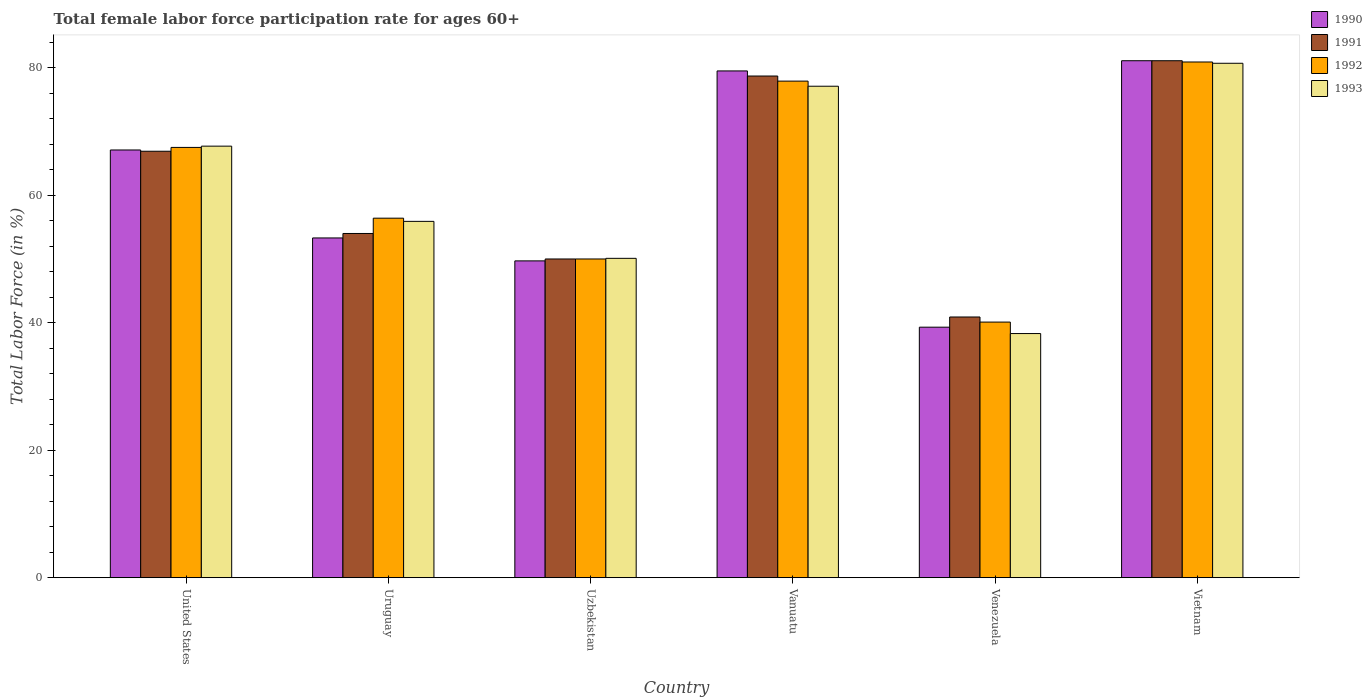How many bars are there on the 1st tick from the left?
Make the answer very short. 4. What is the label of the 4th group of bars from the left?
Your response must be concise. Vanuatu. In how many cases, is the number of bars for a given country not equal to the number of legend labels?
Make the answer very short. 0. What is the female labor force participation rate in 1993 in Uzbekistan?
Your answer should be compact. 50.1. Across all countries, what is the maximum female labor force participation rate in 1992?
Provide a short and direct response. 80.9. Across all countries, what is the minimum female labor force participation rate in 1990?
Your response must be concise. 39.3. In which country was the female labor force participation rate in 1993 maximum?
Provide a succinct answer. Vietnam. In which country was the female labor force participation rate in 1991 minimum?
Make the answer very short. Venezuela. What is the total female labor force participation rate in 1991 in the graph?
Provide a succinct answer. 371.6. What is the difference between the female labor force participation rate in 1991 in United States and that in Venezuela?
Give a very brief answer. 26. What is the difference between the female labor force participation rate in 1993 in Uzbekistan and the female labor force participation rate in 1990 in Venezuela?
Your answer should be compact. 10.8. What is the average female labor force participation rate in 1993 per country?
Your answer should be very brief. 61.63. What is the difference between the female labor force participation rate of/in 1993 and female labor force participation rate of/in 1991 in Uruguay?
Ensure brevity in your answer.  1.9. What is the ratio of the female labor force participation rate in 1991 in Uruguay to that in Venezuela?
Make the answer very short. 1.32. Is the difference between the female labor force participation rate in 1993 in Uruguay and Uzbekistan greater than the difference between the female labor force participation rate in 1991 in Uruguay and Uzbekistan?
Ensure brevity in your answer.  Yes. What is the difference between the highest and the lowest female labor force participation rate in 1993?
Make the answer very short. 42.4. Is the sum of the female labor force participation rate in 1992 in Uruguay and Vietnam greater than the maximum female labor force participation rate in 1990 across all countries?
Make the answer very short. Yes. What does the 4th bar from the left in Uzbekistan represents?
Provide a short and direct response. 1993. What does the 2nd bar from the right in Uzbekistan represents?
Keep it short and to the point. 1992. Are all the bars in the graph horizontal?
Your answer should be very brief. No. How many countries are there in the graph?
Your answer should be compact. 6. What is the difference between two consecutive major ticks on the Y-axis?
Keep it short and to the point. 20. Are the values on the major ticks of Y-axis written in scientific E-notation?
Ensure brevity in your answer.  No. Does the graph contain grids?
Give a very brief answer. No. How many legend labels are there?
Give a very brief answer. 4. How are the legend labels stacked?
Provide a short and direct response. Vertical. What is the title of the graph?
Provide a succinct answer. Total female labor force participation rate for ages 60+. Does "2001" appear as one of the legend labels in the graph?
Ensure brevity in your answer.  No. What is the Total Labor Force (in %) of 1990 in United States?
Your answer should be compact. 67.1. What is the Total Labor Force (in %) of 1991 in United States?
Provide a succinct answer. 66.9. What is the Total Labor Force (in %) in 1992 in United States?
Offer a terse response. 67.5. What is the Total Labor Force (in %) in 1993 in United States?
Provide a succinct answer. 67.7. What is the Total Labor Force (in %) in 1990 in Uruguay?
Your answer should be compact. 53.3. What is the Total Labor Force (in %) in 1991 in Uruguay?
Offer a very short reply. 54. What is the Total Labor Force (in %) in 1992 in Uruguay?
Offer a terse response. 56.4. What is the Total Labor Force (in %) in 1993 in Uruguay?
Offer a very short reply. 55.9. What is the Total Labor Force (in %) of 1990 in Uzbekistan?
Provide a short and direct response. 49.7. What is the Total Labor Force (in %) of 1993 in Uzbekistan?
Provide a succinct answer. 50.1. What is the Total Labor Force (in %) of 1990 in Vanuatu?
Provide a succinct answer. 79.5. What is the Total Labor Force (in %) in 1991 in Vanuatu?
Your response must be concise. 78.7. What is the Total Labor Force (in %) of 1992 in Vanuatu?
Provide a short and direct response. 77.9. What is the Total Labor Force (in %) of 1993 in Vanuatu?
Provide a short and direct response. 77.1. What is the Total Labor Force (in %) in 1990 in Venezuela?
Your answer should be compact. 39.3. What is the Total Labor Force (in %) in 1991 in Venezuela?
Make the answer very short. 40.9. What is the Total Labor Force (in %) in 1992 in Venezuela?
Make the answer very short. 40.1. What is the Total Labor Force (in %) of 1993 in Venezuela?
Offer a very short reply. 38.3. What is the Total Labor Force (in %) of 1990 in Vietnam?
Offer a very short reply. 81.1. What is the Total Labor Force (in %) in 1991 in Vietnam?
Your answer should be very brief. 81.1. What is the Total Labor Force (in %) of 1992 in Vietnam?
Ensure brevity in your answer.  80.9. What is the Total Labor Force (in %) of 1993 in Vietnam?
Give a very brief answer. 80.7. Across all countries, what is the maximum Total Labor Force (in %) in 1990?
Ensure brevity in your answer.  81.1. Across all countries, what is the maximum Total Labor Force (in %) of 1991?
Your answer should be very brief. 81.1. Across all countries, what is the maximum Total Labor Force (in %) in 1992?
Offer a very short reply. 80.9. Across all countries, what is the maximum Total Labor Force (in %) of 1993?
Give a very brief answer. 80.7. Across all countries, what is the minimum Total Labor Force (in %) of 1990?
Keep it short and to the point. 39.3. Across all countries, what is the minimum Total Labor Force (in %) in 1991?
Ensure brevity in your answer.  40.9. Across all countries, what is the minimum Total Labor Force (in %) of 1992?
Give a very brief answer. 40.1. Across all countries, what is the minimum Total Labor Force (in %) of 1993?
Offer a terse response. 38.3. What is the total Total Labor Force (in %) of 1990 in the graph?
Provide a succinct answer. 370. What is the total Total Labor Force (in %) in 1991 in the graph?
Offer a terse response. 371.6. What is the total Total Labor Force (in %) in 1992 in the graph?
Offer a very short reply. 372.8. What is the total Total Labor Force (in %) of 1993 in the graph?
Ensure brevity in your answer.  369.8. What is the difference between the Total Labor Force (in %) in 1992 in United States and that in Uruguay?
Make the answer very short. 11.1. What is the difference between the Total Labor Force (in %) of 1992 in United States and that in Uzbekistan?
Provide a short and direct response. 17.5. What is the difference between the Total Labor Force (in %) in 1993 in United States and that in Uzbekistan?
Keep it short and to the point. 17.6. What is the difference between the Total Labor Force (in %) in 1991 in United States and that in Vanuatu?
Offer a terse response. -11.8. What is the difference between the Total Labor Force (in %) in 1992 in United States and that in Vanuatu?
Provide a short and direct response. -10.4. What is the difference between the Total Labor Force (in %) in 1993 in United States and that in Vanuatu?
Give a very brief answer. -9.4. What is the difference between the Total Labor Force (in %) in 1990 in United States and that in Venezuela?
Make the answer very short. 27.8. What is the difference between the Total Labor Force (in %) in 1991 in United States and that in Venezuela?
Your answer should be compact. 26. What is the difference between the Total Labor Force (in %) in 1992 in United States and that in Venezuela?
Provide a succinct answer. 27.4. What is the difference between the Total Labor Force (in %) in 1993 in United States and that in Venezuela?
Provide a short and direct response. 29.4. What is the difference between the Total Labor Force (in %) of 1990 in United States and that in Vietnam?
Keep it short and to the point. -14. What is the difference between the Total Labor Force (in %) in 1992 in United States and that in Vietnam?
Give a very brief answer. -13.4. What is the difference between the Total Labor Force (in %) in 1993 in United States and that in Vietnam?
Make the answer very short. -13. What is the difference between the Total Labor Force (in %) of 1990 in Uruguay and that in Uzbekistan?
Offer a very short reply. 3.6. What is the difference between the Total Labor Force (in %) in 1992 in Uruguay and that in Uzbekistan?
Give a very brief answer. 6.4. What is the difference between the Total Labor Force (in %) of 1990 in Uruguay and that in Vanuatu?
Your response must be concise. -26.2. What is the difference between the Total Labor Force (in %) in 1991 in Uruguay and that in Vanuatu?
Your response must be concise. -24.7. What is the difference between the Total Labor Force (in %) of 1992 in Uruguay and that in Vanuatu?
Ensure brevity in your answer.  -21.5. What is the difference between the Total Labor Force (in %) of 1993 in Uruguay and that in Vanuatu?
Keep it short and to the point. -21.2. What is the difference between the Total Labor Force (in %) in 1990 in Uruguay and that in Venezuela?
Give a very brief answer. 14. What is the difference between the Total Labor Force (in %) of 1992 in Uruguay and that in Venezuela?
Keep it short and to the point. 16.3. What is the difference between the Total Labor Force (in %) of 1993 in Uruguay and that in Venezuela?
Offer a very short reply. 17.6. What is the difference between the Total Labor Force (in %) of 1990 in Uruguay and that in Vietnam?
Your answer should be very brief. -27.8. What is the difference between the Total Labor Force (in %) of 1991 in Uruguay and that in Vietnam?
Your answer should be compact. -27.1. What is the difference between the Total Labor Force (in %) of 1992 in Uruguay and that in Vietnam?
Make the answer very short. -24.5. What is the difference between the Total Labor Force (in %) of 1993 in Uruguay and that in Vietnam?
Your response must be concise. -24.8. What is the difference between the Total Labor Force (in %) in 1990 in Uzbekistan and that in Vanuatu?
Make the answer very short. -29.8. What is the difference between the Total Labor Force (in %) of 1991 in Uzbekistan and that in Vanuatu?
Ensure brevity in your answer.  -28.7. What is the difference between the Total Labor Force (in %) in 1992 in Uzbekistan and that in Vanuatu?
Give a very brief answer. -27.9. What is the difference between the Total Labor Force (in %) of 1993 in Uzbekistan and that in Venezuela?
Your answer should be very brief. 11.8. What is the difference between the Total Labor Force (in %) of 1990 in Uzbekistan and that in Vietnam?
Offer a very short reply. -31.4. What is the difference between the Total Labor Force (in %) of 1991 in Uzbekistan and that in Vietnam?
Offer a terse response. -31.1. What is the difference between the Total Labor Force (in %) in 1992 in Uzbekistan and that in Vietnam?
Provide a succinct answer. -30.9. What is the difference between the Total Labor Force (in %) in 1993 in Uzbekistan and that in Vietnam?
Provide a succinct answer. -30.6. What is the difference between the Total Labor Force (in %) in 1990 in Vanuatu and that in Venezuela?
Give a very brief answer. 40.2. What is the difference between the Total Labor Force (in %) of 1991 in Vanuatu and that in Venezuela?
Give a very brief answer. 37.8. What is the difference between the Total Labor Force (in %) of 1992 in Vanuatu and that in Venezuela?
Your answer should be compact. 37.8. What is the difference between the Total Labor Force (in %) of 1993 in Vanuatu and that in Venezuela?
Make the answer very short. 38.8. What is the difference between the Total Labor Force (in %) of 1991 in Vanuatu and that in Vietnam?
Provide a short and direct response. -2.4. What is the difference between the Total Labor Force (in %) of 1990 in Venezuela and that in Vietnam?
Give a very brief answer. -41.8. What is the difference between the Total Labor Force (in %) of 1991 in Venezuela and that in Vietnam?
Offer a terse response. -40.2. What is the difference between the Total Labor Force (in %) of 1992 in Venezuela and that in Vietnam?
Offer a very short reply. -40.8. What is the difference between the Total Labor Force (in %) of 1993 in Venezuela and that in Vietnam?
Offer a very short reply. -42.4. What is the difference between the Total Labor Force (in %) of 1990 in United States and the Total Labor Force (in %) of 1992 in Uruguay?
Provide a short and direct response. 10.7. What is the difference between the Total Labor Force (in %) in 1990 in United States and the Total Labor Force (in %) in 1993 in Uruguay?
Make the answer very short. 11.2. What is the difference between the Total Labor Force (in %) in 1991 in United States and the Total Labor Force (in %) in 1993 in Uruguay?
Make the answer very short. 11. What is the difference between the Total Labor Force (in %) of 1990 in United States and the Total Labor Force (in %) of 1993 in Uzbekistan?
Provide a short and direct response. 17. What is the difference between the Total Labor Force (in %) of 1991 in United States and the Total Labor Force (in %) of 1992 in Uzbekistan?
Offer a terse response. 16.9. What is the difference between the Total Labor Force (in %) of 1991 in United States and the Total Labor Force (in %) of 1993 in Uzbekistan?
Ensure brevity in your answer.  16.8. What is the difference between the Total Labor Force (in %) in 1991 in United States and the Total Labor Force (in %) in 1993 in Vanuatu?
Give a very brief answer. -10.2. What is the difference between the Total Labor Force (in %) in 1992 in United States and the Total Labor Force (in %) in 1993 in Vanuatu?
Offer a terse response. -9.6. What is the difference between the Total Labor Force (in %) of 1990 in United States and the Total Labor Force (in %) of 1991 in Venezuela?
Your answer should be very brief. 26.2. What is the difference between the Total Labor Force (in %) in 1990 in United States and the Total Labor Force (in %) in 1992 in Venezuela?
Provide a short and direct response. 27. What is the difference between the Total Labor Force (in %) of 1990 in United States and the Total Labor Force (in %) of 1993 in Venezuela?
Give a very brief answer. 28.8. What is the difference between the Total Labor Force (in %) in 1991 in United States and the Total Labor Force (in %) in 1992 in Venezuela?
Provide a succinct answer. 26.8. What is the difference between the Total Labor Force (in %) of 1991 in United States and the Total Labor Force (in %) of 1993 in Venezuela?
Your response must be concise. 28.6. What is the difference between the Total Labor Force (in %) in 1992 in United States and the Total Labor Force (in %) in 1993 in Venezuela?
Provide a short and direct response. 29.2. What is the difference between the Total Labor Force (in %) in 1990 in United States and the Total Labor Force (in %) in 1991 in Vietnam?
Ensure brevity in your answer.  -14. What is the difference between the Total Labor Force (in %) in 1990 in United States and the Total Labor Force (in %) in 1992 in Vietnam?
Give a very brief answer. -13.8. What is the difference between the Total Labor Force (in %) of 1991 in United States and the Total Labor Force (in %) of 1993 in Vietnam?
Provide a succinct answer. -13.8. What is the difference between the Total Labor Force (in %) of 1990 in Uruguay and the Total Labor Force (in %) of 1992 in Uzbekistan?
Your response must be concise. 3.3. What is the difference between the Total Labor Force (in %) in 1991 in Uruguay and the Total Labor Force (in %) in 1992 in Uzbekistan?
Provide a succinct answer. 4. What is the difference between the Total Labor Force (in %) in 1991 in Uruguay and the Total Labor Force (in %) in 1993 in Uzbekistan?
Keep it short and to the point. 3.9. What is the difference between the Total Labor Force (in %) in 1992 in Uruguay and the Total Labor Force (in %) in 1993 in Uzbekistan?
Keep it short and to the point. 6.3. What is the difference between the Total Labor Force (in %) in 1990 in Uruguay and the Total Labor Force (in %) in 1991 in Vanuatu?
Your answer should be very brief. -25.4. What is the difference between the Total Labor Force (in %) of 1990 in Uruguay and the Total Labor Force (in %) of 1992 in Vanuatu?
Your answer should be compact. -24.6. What is the difference between the Total Labor Force (in %) of 1990 in Uruguay and the Total Labor Force (in %) of 1993 in Vanuatu?
Offer a very short reply. -23.8. What is the difference between the Total Labor Force (in %) of 1991 in Uruguay and the Total Labor Force (in %) of 1992 in Vanuatu?
Ensure brevity in your answer.  -23.9. What is the difference between the Total Labor Force (in %) in 1991 in Uruguay and the Total Labor Force (in %) in 1993 in Vanuatu?
Give a very brief answer. -23.1. What is the difference between the Total Labor Force (in %) in 1992 in Uruguay and the Total Labor Force (in %) in 1993 in Vanuatu?
Make the answer very short. -20.7. What is the difference between the Total Labor Force (in %) of 1991 in Uruguay and the Total Labor Force (in %) of 1992 in Venezuela?
Your answer should be compact. 13.9. What is the difference between the Total Labor Force (in %) in 1991 in Uruguay and the Total Labor Force (in %) in 1993 in Venezuela?
Your answer should be very brief. 15.7. What is the difference between the Total Labor Force (in %) in 1992 in Uruguay and the Total Labor Force (in %) in 1993 in Venezuela?
Offer a terse response. 18.1. What is the difference between the Total Labor Force (in %) of 1990 in Uruguay and the Total Labor Force (in %) of 1991 in Vietnam?
Your response must be concise. -27.8. What is the difference between the Total Labor Force (in %) in 1990 in Uruguay and the Total Labor Force (in %) in 1992 in Vietnam?
Offer a very short reply. -27.6. What is the difference between the Total Labor Force (in %) in 1990 in Uruguay and the Total Labor Force (in %) in 1993 in Vietnam?
Offer a very short reply. -27.4. What is the difference between the Total Labor Force (in %) of 1991 in Uruguay and the Total Labor Force (in %) of 1992 in Vietnam?
Your response must be concise. -26.9. What is the difference between the Total Labor Force (in %) of 1991 in Uruguay and the Total Labor Force (in %) of 1993 in Vietnam?
Give a very brief answer. -26.7. What is the difference between the Total Labor Force (in %) in 1992 in Uruguay and the Total Labor Force (in %) in 1993 in Vietnam?
Keep it short and to the point. -24.3. What is the difference between the Total Labor Force (in %) of 1990 in Uzbekistan and the Total Labor Force (in %) of 1992 in Vanuatu?
Offer a terse response. -28.2. What is the difference between the Total Labor Force (in %) in 1990 in Uzbekistan and the Total Labor Force (in %) in 1993 in Vanuatu?
Give a very brief answer. -27.4. What is the difference between the Total Labor Force (in %) of 1991 in Uzbekistan and the Total Labor Force (in %) of 1992 in Vanuatu?
Keep it short and to the point. -27.9. What is the difference between the Total Labor Force (in %) of 1991 in Uzbekistan and the Total Labor Force (in %) of 1993 in Vanuatu?
Provide a succinct answer. -27.1. What is the difference between the Total Labor Force (in %) in 1992 in Uzbekistan and the Total Labor Force (in %) in 1993 in Vanuatu?
Your answer should be compact. -27.1. What is the difference between the Total Labor Force (in %) in 1990 in Uzbekistan and the Total Labor Force (in %) in 1991 in Venezuela?
Give a very brief answer. 8.8. What is the difference between the Total Labor Force (in %) in 1991 in Uzbekistan and the Total Labor Force (in %) in 1992 in Venezuela?
Your answer should be very brief. 9.9. What is the difference between the Total Labor Force (in %) of 1990 in Uzbekistan and the Total Labor Force (in %) of 1991 in Vietnam?
Your answer should be compact. -31.4. What is the difference between the Total Labor Force (in %) in 1990 in Uzbekistan and the Total Labor Force (in %) in 1992 in Vietnam?
Your answer should be very brief. -31.2. What is the difference between the Total Labor Force (in %) of 1990 in Uzbekistan and the Total Labor Force (in %) of 1993 in Vietnam?
Make the answer very short. -31. What is the difference between the Total Labor Force (in %) of 1991 in Uzbekistan and the Total Labor Force (in %) of 1992 in Vietnam?
Offer a very short reply. -30.9. What is the difference between the Total Labor Force (in %) of 1991 in Uzbekistan and the Total Labor Force (in %) of 1993 in Vietnam?
Offer a very short reply. -30.7. What is the difference between the Total Labor Force (in %) in 1992 in Uzbekistan and the Total Labor Force (in %) in 1993 in Vietnam?
Your answer should be compact. -30.7. What is the difference between the Total Labor Force (in %) of 1990 in Vanuatu and the Total Labor Force (in %) of 1991 in Venezuela?
Give a very brief answer. 38.6. What is the difference between the Total Labor Force (in %) in 1990 in Vanuatu and the Total Labor Force (in %) in 1992 in Venezuela?
Offer a very short reply. 39.4. What is the difference between the Total Labor Force (in %) of 1990 in Vanuatu and the Total Labor Force (in %) of 1993 in Venezuela?
Make the answer very short. 41.2. What is the difference between the Total Labor Force (in %) in 1991 in Vanuatu and the Total Labor Force (in %) in 1992 in Venezuela?
Offer a very short reply. 38.6. What is the difference between the Total Labor Force (in %) of 1991 in Vanuatu and the Total Labor Force (in %) of 1993 in Venezuela?
Provide a succinct answer. 40.4. What is the difference between the Total Labor Force (in %) of 1992 in Vanuatu and the Total Labor Force (in %) of 1993 in Venezuela?
Give a very brief answer. 39.6. What is the difference between the Total Labor Force (in %) in 1990 in Vanuatu and the Total Labor Force (in %) in 1991 in Vietnam?
Make the answer very short. -1.6. What is the difference between the Total Labor Force (in %) in 1991 in Vanuatu and the Total Labor Force (in %) in 1993 in Vietnam?
Offer a very short reply. -2. What is the difference between the Total Labor Force (in %) of 1990 in Venezuela and the Total Labor Force (in %) of 1991 in Vietnam?
Make the answer very short. -41.8. What is the difference between the Total Labor Force (in %) of 1990 in Venezuela and the Total Labor Force (in %) of 1992 in Vietnam?
Your answer should be compact. -41.6. What is the difference between the Total Labor Force (in %) of 1990 in Venezuela and the Total Labor Force (in %) of 1993 in Vietnam?
Make the answer very short. -41.4. What is the difference between the Total Labor Force (in %) in 1991 in Venezuela and the Total Labor Force (in %) in 1992 in Vietnam?
Provide a succinct answer. -40. What is the difference between the Total Labor Force (in %) of 1991 in Venezuela and the Total Labor Force (in %) of 1993 in Vietnam?
Make the answer very short. -39.8. What is the difference between the Total Labor Force (in %) of 1992 in Venezuela and the Total Labor Force (in %) of 1993 in Vietnam?
Your answer should be very brief. -40.6. What is the average Total Labor Force (in %) of 1990 per country?
Provide a short and direct response. 61.67. What is the average Total Labor Force (in %) of 1991 per country?
Provide a short and direct response. 61.93. What is the average Total Labor Force (in %) of 1992 per country?
Keep it short and to the point. 62.13. What is the average Total Labor Force (in %) of 1993 per country?
Provide a succinct answer. 61.63. What is the difference between the Total Labor Force (in %) of 1990 and Total Labor Force (in %) of 1991 in United States?
Keep it short and to the point. 0.2. What is the difference between the Total Labor Force (in %) in 1990 and Total Labor Force (in %) in 1992 in United States?
Make the answer very short. -0.4. What is the difference between the Total Labor Force (in %) of 1990 and Total Labor Force (in %) of 1993 in United States?
Your answer should be compact. -0.6. What is the difference between the Total Labor Force (in %) in 1991 and Total Labor Force (in %) in 1992 in United States?
Offer a very short reply. -0.6. What is the difference between the Total Labor Force (in %) in 1990 and Total Labor Force (in %) in 1991 in Uruguay?
Make the answer very short. -0.7. What is the difference between the Total Labor Force (in %) of 1990 and Total Labor Force (in %) of 1993 in Uruguay?
Ensure brevity in your answer.  -2.6. What is the difference between the Total Labor Force (in %) of 1991 and Total Labor Force (in %) of 1993 in Uruguay?
Offer a very short reply. -1.9. What is the difference between the Total Labor Force (in %) of 1992 and Total Labor Force (in %) of 1993 in Uruguay?
Offer a terse response. 0.5. What is the difference between the Total Labor Force (in %) of 1990 and Total Labor Force (in %) of 1993 in Uzbekistan?
Provide a short and direct response. -0.4. What is the difference between the Total Labor Force (in %) in 1992 and Total Labor Force (in %) in 1993 in Uzbekistan?
Provide a succinct answer. -0.1. What is the difference between the Total Labor Force (in %) of 1990 and Total Labor Force (in %) of 1991 in Vanuatu?
Ensure brevity in your answer.  0.8. What is the difference between the Total Labor Force (in %) in 1991 and Total Labor Force (in %) in 1992 in Vanuatu?
Provide a succinct answer. 0.8. What is the difference between the Total Labor Force (in %) of 1992 and Total Labor Force (in %) of 1993 in Vanuatu?
Your response must be concise. 0.8. What is the difference between the Total Labor Force (in %) of 1990 and Total Labor Force (in %) of 1991 in Venezuela?
Your response must be concise. -1.6. What is the difference between the Total Labor Force (in %) of 1990 and Total Labor Force (in %) of 1993 in Venezuela?
Offer a terse response. 1. What is the difference between the Total Labor Force (in %) of 1991 and Total Labor Force (in %) of 1992 in Venezuela?
Keep it short and to the point. 0.8. What is the difference between the Total Labor Force (in %) in 1990 and Total Labor Force (in %) in 1991 in Vietnam?
Your answer should be compact. 0. What is the difference between the Total Labor Force (in %) in 1990 and Total Labor Force (in %) in 1993 in Vietnam?
Give a very brief answer. 0.4. What is the difference between the Total Labor Force (in %) of 1991 and Total Labor Force (in %) of 1993 in Vietnam?
Your answer should be compact. 0.4. What is the difference between the Total Labor Force (in %) of 1992 and Total Labor Force (in %) of 1993 in Vietnam?
Give a very brief answer. 0.2. What is the ratio of the Total Labor Force (in %) of 1990 in United States to that in Uruguay?
Provide a short and direct response. 1.26. What is the ratio of the Total Labor Force (in %) in 1991 in United States to that in Uruguay?
Make the answer very short. 1.24. What is the ratio of the Total Labor Force (in %) in 1992 in United States to that in Uruguay?
Your answer should be very brief. 1.2. What is the ratio of the Total Labor Force (in %) in 1993 in United States to that in Uruguay?
Provide a succinct answer. 1.21. What is the ratio of the Total Labor Force (in %) of 1990 in United States to that in Uzbekistan?
Offer a very short reply. 1.35. What is the ratio of the Total Labor Force (in %) of 1991 in United States to that in Uzbekistan?
Ensure brevity in your answer.  1.34. What is the ratio of the Total Labor Force (in %) in 1992 in United States to that in Uzbekistan?
Give a very brief answer. 1.35. What is the ratio of the Total Labor Force (in %) of 1993 in United States to that in Uzbekistan?
Your response must be concise. 1.35. What is the ratio of the Total Labor Force (in %) of 1990 in United States to that in Vanuatu?
Your response must be concise. 0.84. What is the ratio of the Total Labor Force (in %) in 1991 in United States to that in Vanuatu?
Provide a succinct answer. 0.85. What is the ratio of the Total Labor Force (in %) in 1992 in United States to that in Vanuatu?
Offer a very short reply. 0.87. What is the ratio of the Total Labor Force (in %) in 1993 in United States to that in Vanuatu?
Provide a succinct answer. 0.88. What is the ratio of the Total Labor Force (in %) of 1990 in United States to that in Venezuela?
Make the answer very short. 1.71. What is the ratio of the Total Labor Force (in %) in 1991 in United States to that in Venezuela?
Provide a short and direct response. 1.64. What is the ratio of the Total Labor Force (in %) of 1992 in United States to that in Venezuela?
Ensure brevity in your answer.  1.68. What is the ratio of the Total Labor Force (in %) in 1993 in United States to that in Venezuela?
Your response must be concise. 1.77. What is the ratio of the Total Labor Force (in %) in 1990 in United States to that in Vietnam?
Offer a very short reply. 0.83. What is the ratio of the Total Labor Force (in %) of 1991 in United States to that in Vietnam?
Provide a succinct answer. 0.82. What is the ratio of the Total Labor Force (in %) of 1992 in United States to that in Vietnam?
Your answer should be very brief. 0.83. What is the ratio of the Total Labor Force (in %) in 1993 in United States to that in Vietnam?
Provide a succinct answer. 0.84. What is the ratio of the Total Labor Force (in %) in 1990 in Uruguay to that in Uzbekistan?
Keep it short and to the point. 1.07. What is the ratio of the Total Labor Force (in %) in 1992 in Uruguay to that in Uzbekistan?
Ensure brevity in your answer.  1.13. What is the ratio of the Total Labor Force (in %) in 1993 in Uruguay to that in Uzbekistan?
Provide a short and direct response. 1.12. What is the ratio of the Total Labor Force (in %) of 1990 in Uruguay to that in Vanuatu?
Make the answer very short. 0.67. What is the ratio of the Total Labor Force (in %) of 1991 in Uruguay to that in Vanuatu?
Provide a short and direct response. 0.69. What is the ratio of the Total Labor Force (in %) in 1992 in Uruguay to that in Vanuatu?
Make the answer very short. 0.72. What is the ratio of the Total Labor Force (in %) in 1993 in Uruguay to that in Vanuatu?
Ensure brevity in your answer.  0.72. What is the ratio of the Total Labor Force (in %) of 1990 in Uruguay to that in Venezuela?
Your answer should be very brief. 1.36. What is the ratio of the Total Labor Force (in %) in 1991 in Uruguay to that in Venezuela?
Offer a very short reply. 1.32. What is the ratio of the Total Labor Force (in %) in 1992 in Uruguay to that in Venezuela?
Provide a short and direct response. 1.41. What is the ratio of the Total Labor Force (in %) of 1993 in Uruguay to that in Venezuela?
Your answer should be compact. 1.46. What is the ratio of the Total Labor Force (in %) in 1990 in Uruguay to that in Vietnam?
Make the answer very short. 0.66. What is the ratio of the Total Labor Force (in %) in 1991 in Uruguay to that in Vietnam?
Offer a very short reply. 0.67. What is the ratio of the Total Labor Force (in %) in 1992 in Uruguay to that in Vietnam?
Offer a very short reply. 0.7. What is the ratio of the Total Labor Force (in %) of 1993 in Uruguay to that in Vietnam?
Your answer should be compact. 0.69. What is the ratio of the Total Labor Force (in %) in 1990 in Uzbekistan to that in Vanuatu?
Give a very brief answer. 0.63. What is the ratio of the Total Labor Force (in %) in 1991 in Uzbekistan to that in Vanuatu?
Offer a very short reply. 0.64. What is the ratio of the Total Labor Force (in %) of 1992 in Uzbekistan to that in Vanuatu?
Offer a very short reply. 0.64. What is the ratio of the Total Labor Force (in %) in 1993 in Uzbekistan to that in Vanuatu?
Your response must be concise. 0.65. What is the ratio of the Total Labor Force (in %) of 1990 in Uzbekistan to that in Venezuela?
Keep it short and to the point. 1.26. What is the ratio of the Total Labor Force (in %) of 1991 in Uzbekistan to that in Venezuela?
Provide a succinct answer. 1.22. What is the ratio of the Total Labor Force (in %) of 1992 in Uzbekistan to that in Venezuela?
Your answer should be very brief. 1.25. What is the ratio of the Total Labor Force (in %) in 1993 in Uzbekistan to that in Venezuela?
Provide a succinct answer. 1.31. What is the ratio of the Total Labor Force (in %) of 1990 in Uzbekistan to that in Vietnam?
Provide a short and direct response. 0.61. What is the ratio of the Total Labor Force (in %) in 1991 in Uzbekistan to that in Vietnam?
Keep it short and to the point. 0.62. What is the ratio of the Total Labor Force (in %) in 1992 in Uzbekistan to that in Vietnam?
Your answer should be compact. 0.62. What is the ratio of the Total Labor Force (in %) in 1993 in Uzbekistan to that in Vietnam?
Ensure brevity in your answer.  0.62. What is the ratio of the Total Labor Force (in %) in 1990 in Vanuatu to that in Venezuela?
Keep it short and to the point. 2.02. What is the ratio of the Total Labor Force (in %) in 1991 in Vanuatu to that in Venezuela?
Provide a short and direct response. 1.92. What is the ratio of the Total Labor Force (in %) of 1992 in Vanuatu to that in Venezuela?
Keep it short and to the point. 1.94. What is the ratio of the Total Labor Force (in %) of 1993 in Vanuatu to that in Venezuela?
Offer a very short reply. 2.01. What is the ratio of the Total Labor Force (in %) of 1990 in Vanuatu to that in Vietnam?
Give a very brief answer. 0.98. What is the ratio of the Total Labor Force (in %) in 1991 in Vanuatu to that in Vietnam?
Provide a short and direct response. 0.97. What is the ratio of the Total Labor Force (in %) in 1992 in Vanuatu to that in Vietnam?
Ensure brevity in your answer.  0.96. What is the ratio of the Total Labor Force (in %) in 1993 in Vanuatu to that in Vietnam?
Provide a short and direct response. 0.96. What is the ratio of the Total Labor Force (in %) in 1990 in Venezuela to that in Vietnam?
Keep it short and to the point. 0.48. What is the ratio of the Total Labor Force (in %) in 1991 in Venezuela to that in Vietnam?
Ensure brevity in your answer.  0.5. What is the ratio of the Total Labor Force (in %) of 1992 in Venezuela to that in Vietnam?
Your answer should be very brief. 0.5. What is the ratio of the Total Labor Force (in %) in 1993 in Venezuela to that in Vietnam?
Provide a succinct answer. 0.47. What is the difference between the highest and the second highest Total Labor Force (in %) of 1990?
Your answer should be compact. 1.6. What is the difference between the highest and the second highest Total Labor Force (in %) in 1993?
Ensure brevity in your answer.  3.6. What is the difference between the highest and the lowest Total Labor Force (in %) in 1990?
Your response must be concise. 41.8. What is the difference between the highest and the lowest Total Labor Force (in %) of 1991?
Your answer should be compact. 40.2. What is the difference between the highest and the lowest Total Labor Force (in %) of 1992?
Offer a terse response. 40.8. What is the difference between the highest and the lowest Total Labor Force (in %) of 1993?
Your answer should be compact. 42.4. 